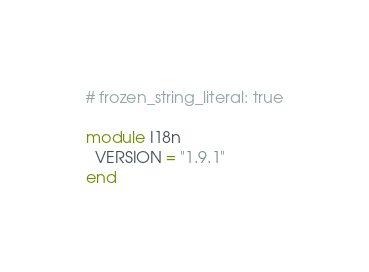<code> <loc_0><loc_0><loc_500><loc_500><_Ruby_># frozen_string_literal: true

module I18n
  VERSION = "1.9.1"
end
</code> 